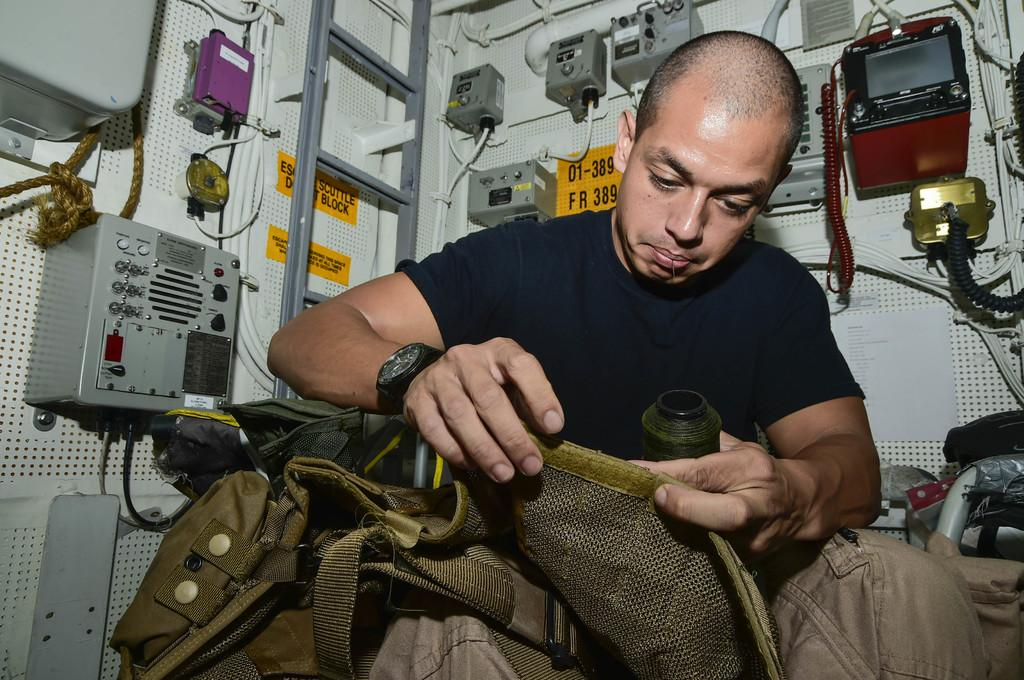Who is present in the image? There is a man in the image. What is the man doing in the image? The man is doing some work in the image. What specific tools or equipment can be seen in the image? There are different current meters and other machines in the image. What type of lunch is the man eating in the image? There is no lunch present in the image; the man is working with current meters and other machines. 